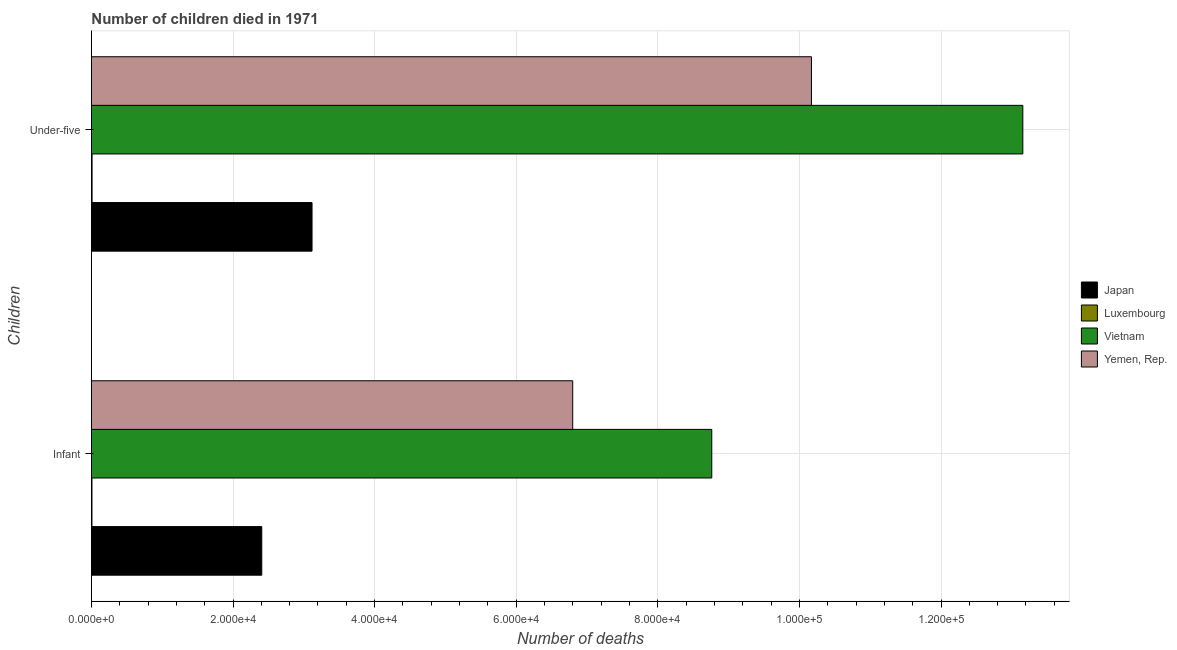How many different coloured bars are there?
Offer a very short reply. 4. How many groups of bars are there?
Offer a very short reply. 2. Are the number of bars per tick equal to the number of legend labels?
Make the answer very short. Yes. How many bars are there on the 2nd tick from the top?
Offer a terse response. 4. How many bars are there on the 2nd tick from the bottom?
Keep it short and to the point. 4. What is the label of the 2nd group of bars from the top?
Your answer should be very brief. Infant. What is the number of infant deaths in Japan?
Offer a terse response. 2.41e+04. Across all countries, what is the maximum number of under-five deaths?
Your answer should be compact. 1.32e+05. Across all countries, what is the minimum number of infant deaths?
Ensure brevity in your answer.  78. In which country was the number of infant deaths maximum?
Your answer should be very brief. Vietnam. In which country was the number of under-five deaths minimum?
Offer a terse response. Luxembourg. What is the total number of under-five deaths in the graph?
Keep it short and to the point. 2.65e+05. What is the difference between the number of infant deaths in Luxembourg and that in Japan?
Keep it short and to the point. -2.40e+04. What is the difference between the number of under-five deaths in Luxembourg and the number of infant deaths in Vietnam?
Offer a very short reply. -8.75e+04. What is the average number of under-five deaths per country?
Ensure brevity in your answer.  6.61e+04. What is the difference between the number of under-five deaths and number of infant deaths in Japan?
Offer a terse response. 7100. What is the ratio of the number of infant deaths in Yemen, Rep. to that in Luxembourg?
Your answer should be compact. 871.54. Is the number of infant deaths in Luxembourg less than that in Yemen, Rep.?
Your answer should be very brief. Yes. What does the 2nd bar from the top in Infant represents?
Make the answer very short. Vietnam. What does the 2nd bar from the bottom in Infant represents?
Keep it short and to the point. Luxembourg. Are all the bars in the graph horizontal?
Provide a succinct answer. Yes. How many countries are there in the graph?
Provide a short and direct response. 4. What is the difference between two consecutive major ticks on the X-axis?
Keep it short and to the point. 2.00e+04. Are the values on the major ticks of X-axis written in scientific E-notation?
Keep it short and to the point. Yes. Does the graph contain any zero values?
Your answer should be very brief. No. How many legend labels are there?
Your answer should be very brief. 4. What is the title of the graph?
Make the answer very short. Number of children died in 1971. Does "Albania" appear as one of the legend labels in the graph?
Keep it short and to the point. No. What is the label or title of the X-axis?
Your answer should be very brief. Number of deaths. What is the label or title of the Y-axis?
Provide a short and direct response. Children. What is the Number of deaths of Japan in Infant?
Make the answer very short. 2.41e+04. What is the Number of deaths of Vietnam in Infant?
Give a very brief answer. 8.76e+04. What is the Number of deaths in Yemen, Rep. in Infant?
Your answer should be very brief. 6.80e+04. What is the Number of deaths in Japan in Under-five?
Provide a short and direct response. 3.12e+04. What is the Number of deaths of Luxembourg in Under-five?
Keep it short and to the point. 93. What is the Number of deaths in Vietnam in Under-five?
Provide a succinct answer. 1.32e+05. What is the Number of deaths of Yemen, Rep. in Under-five?
Give a very brief answer. 1.02e+05. Across all Children, what is the maximum Number of deaths of Japan?
Offer a very short reply. 3.12e+04. Across all Children, what is the maximum Number of deaths in Luxembourg?
Provide a succinct answer. 93. Across all Children, what is the maximum Number of deaths of Vietnam?
Provide a short and direct response. 1.32e+05. Across all Children, what is the maximum Number of deaths in Yemen, Rep.?
Your response must be concise. 1.02e+05. Across all Children, what is the minimum Number of deaths of Japan?
Ensure brevity in your answer.  2.41e+04. Across all Children, what is the minimum Number of deaths in Vietnam?
Give a very brief answer. 8.76e+04. Across all Children, what is the minimum Number of deaths in Yemen, Rep.?
Offer a terse response. 6.80e+04. What is the total Number of deaths of Japan in the graph?
Your answer should be very brief. 5.52e+04. What is the total Number of deaths in Luxembourg in the graph?
Your answer should be very brief. 171. What is the total Number of deaths of Vietnam in the graph?
Make the answer very short. 2.19e+05. What is the total Number of deaths of Yemen, Rep. in the graph?
Your response must be concise. 1.70e+05. What is the difference between the Number of deaths in Japan in Infant and that in Under-five?
Ensure brevity in your answer.  -7100. What is the difference between the Number of deaths of Luxembourg in Infant and that in Under-five?
Give a very brief answer. -15. What is the difference between the Number of deaths in Vietnam in Infant and that in Under-five?
Make the answer very short. -4.39e+04. What is the difference between the Number of deaths in Yemen, Rep. in Infant and that in Under-five?
Keep it short and to the point. -3.37e+04. What is the difference between the Number of deaths in Japan in Infant and the Number of deaths in Luxembourg in Under-five?
Your answer should be compact. 2.40e+04. What is the difference between the Number of deaths in Japan in Infant and the Number of deaths in Vietnam in Under-five?
Provide a short and direct response. -1.07e+05. What is the difference between the Number of deaths in Japan in Infant and the Number of deaths in Yemen, Rep. in Under-five?
Make the answer very short. -7.76e+04. What is the difference between the Number of deaths in Luxembourg in Infant and the Number of deaths in Vietnam in Under-five?
Give a very brief answer. -1.31e+05. What is the difference between the Number of deaths in Luxembourg in Infant and the Number of deaths in Yemen, Rep. in Under-five?
Make the answer very short. -1.02e+05. What is the difference between the Number of deaths of Vietnam in Infant and the Number of deaths of Yemen, Rep. in Under-five?
Your answer should be very brief. -1.41e+04. What is the average Number of deaths in Japan per Children?
Your response must be concise. 2.76e+04. What is the average Number of deaths of Luxembourg per Children?
Offer a very short reply. 85.5. What is the average Number of deaths in Vietnam per Children?
Keep it short and to the point. 1.10e+05. What is the average Number of deaths in Yemen, Rep. per Children?
Your response must be concise. 8.48e+04. What is the difference between the Number of deaths of Japan and Number of deaths of Luxembourg in Infant?
Your answer should be very brief. 2.40e+04. What is the difference between the Number of deaths in Japan and Number of deaths in Vietnam in Infant?
Ensure brevity in your answer.  -6.36e+04. What is the difference between the Number of deaths in Japan and Number of deaths in Yemen, Rep. in Infant?
Offer a terse response. -4.39e+04. What is the difference between the Number of deaths in Luxembourg and Number of deaths in Vietnam in Infant?
Offer a terse response. -8.75e+04. What is the difference between the Number of deaths in Luxembourg and Number of deaths in Yemen, Rep. in Infant?
Provide a short and direct response. -6.79e+04. What is the difference between the Number of deaths in Vietnam and Number of deaths in Yemen, Rep. in Infant?
Your answer should be very brief. 1.96e+04. What is the difference between the Number of deaths in Japan and Number of deaths in Luxembourg in Under-five?
Give a very brief answer. 3.11e+04. What is the difference between the Number of deaths in Japan and Number of deaths in Vietnam in Under-five?
Your answer should be very brief. -1.00e+05. What is the difference between the Number of deaths of Japan and Number of deaths of Yemen, Rep. in Under-five?
Ensure brevity in your answer.  -7.05e+04. What is the difference between the Number of deaths of Luxembourg and Number of deaths of Vietnam in Under-five?
Your answer should be compact. -1.31e+05. What is the difference between the Number of deaths of Luxembourg and Number of deaths of Yemen, Rep. in Under-five?
Your response must be concise. -1.02e+05. What is the difference between the Number of deaths of Vietnam and Number of deaths of Yemen, Rep. in Under-five?
Provide a short and direct response. 2.99e+04. What is the ratio of the Number of deaths in Japan in Infant to that in Under-five?
Offer a very short reply. 0.77. What is the ratio of the Number of deaths of Luxembourg in Infant to that in Under-five?
Make the answer very short. 0.84. What is the ratio of the Number of deaths in Vietnam in Infant to that in Under-five?
Offer a very short reply. 0.67. What is the ratio of the Number of deaths of Yemen, Rep. in Infant to that in Under-five?
Make the answer very short. 0.67. What is the difference between the highest and the second highest Number of deaths in Japan?
Ensure brevity in your answer.  7100. What is the difference between the highest and the second highest Number of deaths of Vietnam?
Ensure brevity in your answer.  4.39e+04. What is the difference between the highest and the second highest Number of deaths in Yemen, Rep.?
Offer a very short reply. 3.37e+04. What is the difference between the highest and the lowest Number of deaths of Japan?
Ensure brevity in your answer.  7100. What is the difference between the highest and the lowest Number of deaths in Vietnam?
Offer a terse response. 4.39e+04. What is the difference between the highest and the lowest Number of deaths in Yemen, Rep.?
Offer a very short reply. 3.37e+04. 